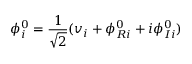<formula> <loc_0><loc_0><loc_500><loc_500>\phi _ { i } ^ { 0 } = { \frac { 1 } { \sqrt { 2 } } } ( v _ { i } + \phi _ { R i } ^ { 0 } + i \phi _ { I i } ^ { 0 } )</formula> 